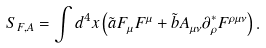Convert formula to latex. <formula><loc_0><loc_0><loc_500><loc_500>S _ { F , A } = \int d ^ { 4 } x \left ( \tilde { a } F _ { \mu } F ^ { \mu } + \tilde { b } A _ { \mu \nu } \partial _ { \rho } ^ { * } F ^ { \rho \mu \nu } \right ) .</formula> 